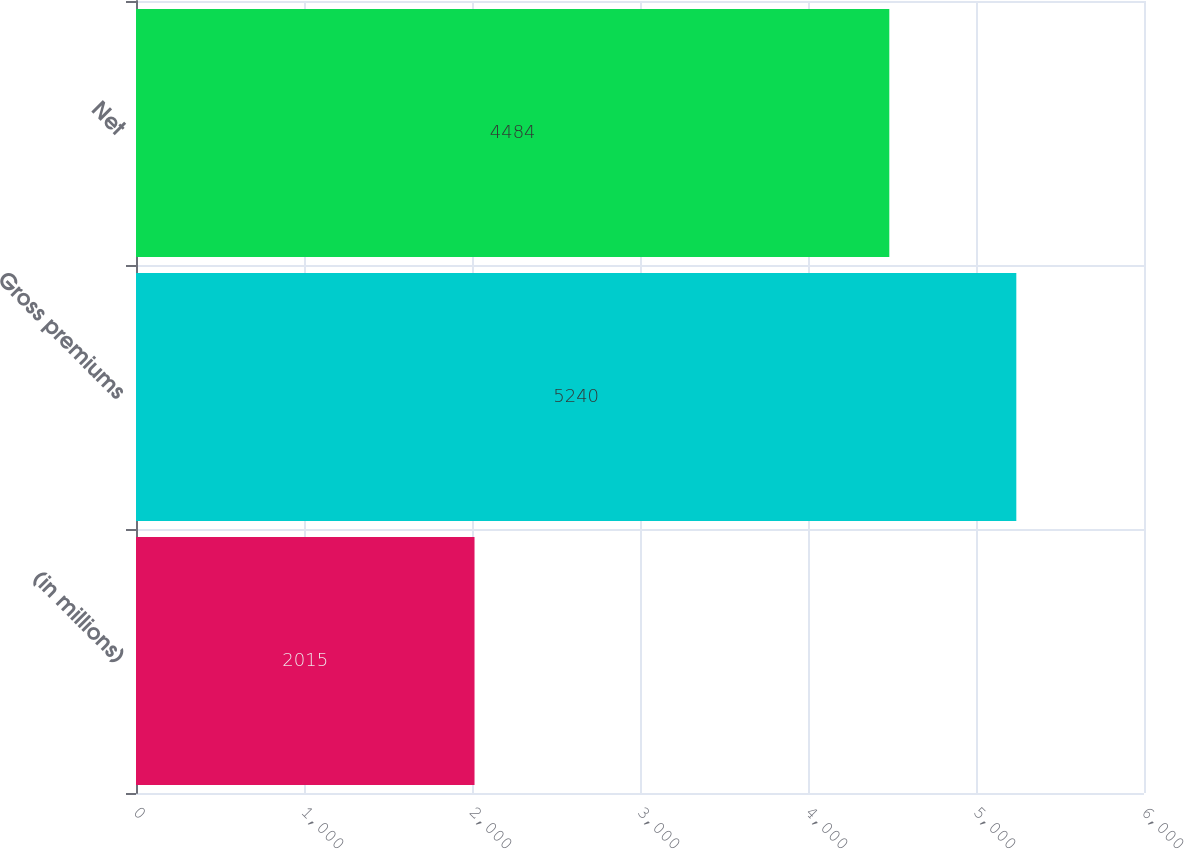Convert chart to OTSL. <chart><loc_0><loc_0><loc_500><loc_500><bar_chart><fcel>(in millions)<fcel>Gross premiums<fcel>Net<nl><fcel>2015<fcel>5240<fcel>4484<nl></chart> 